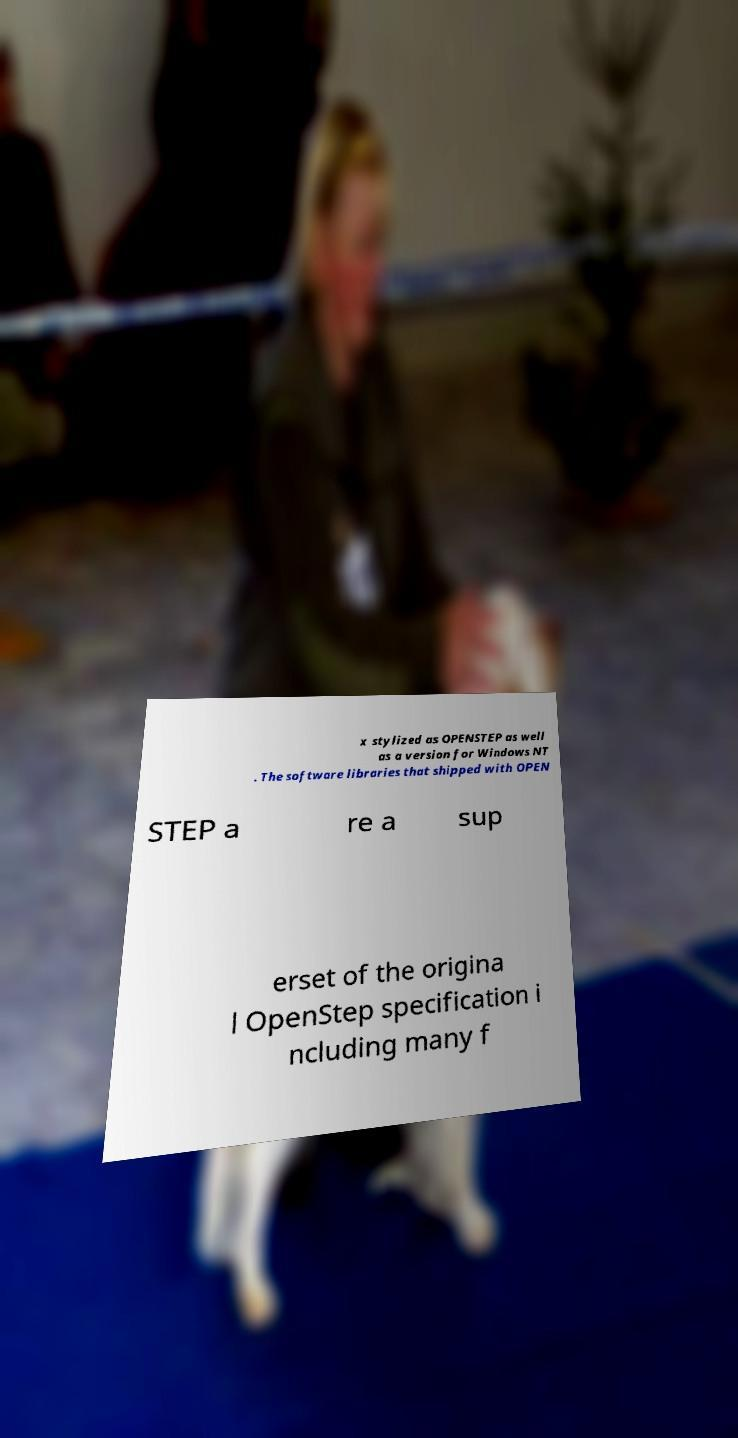I need the written content from this picture converted into text. Can you do that? x stylized as OPENSTEP as well as a version for Windows NT . The software libraries that shipped with OPEN STEP a re a sup erset of the origina l OpenStep specification i ncluding many f 